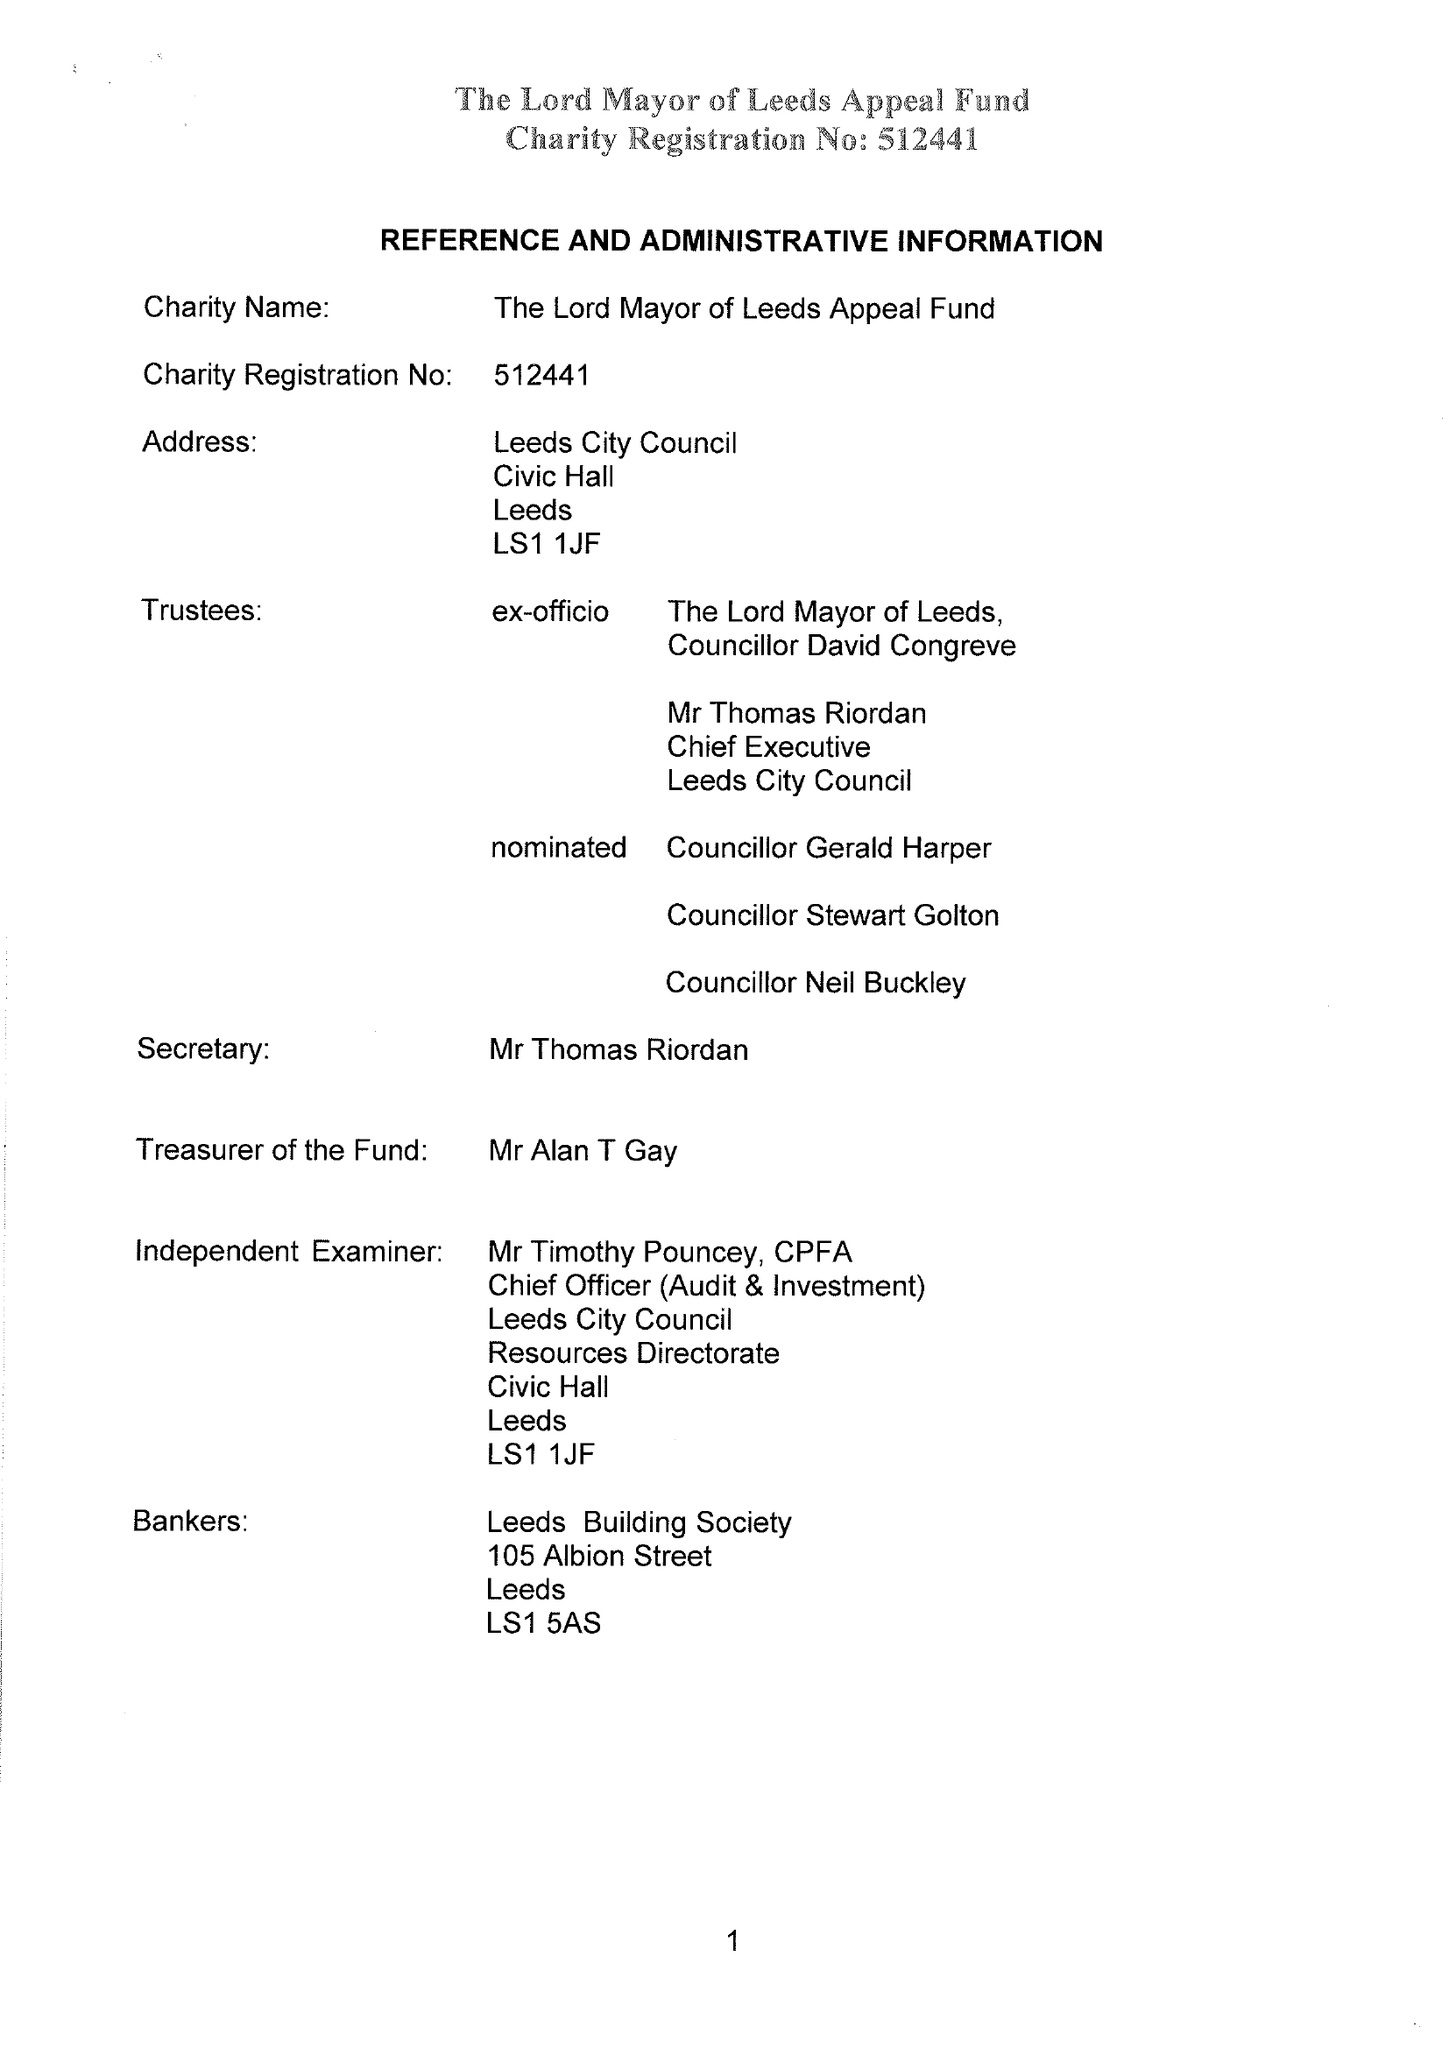What is the value for the address__post_town?
Answer the question using a single word or phrase. LEEDS 